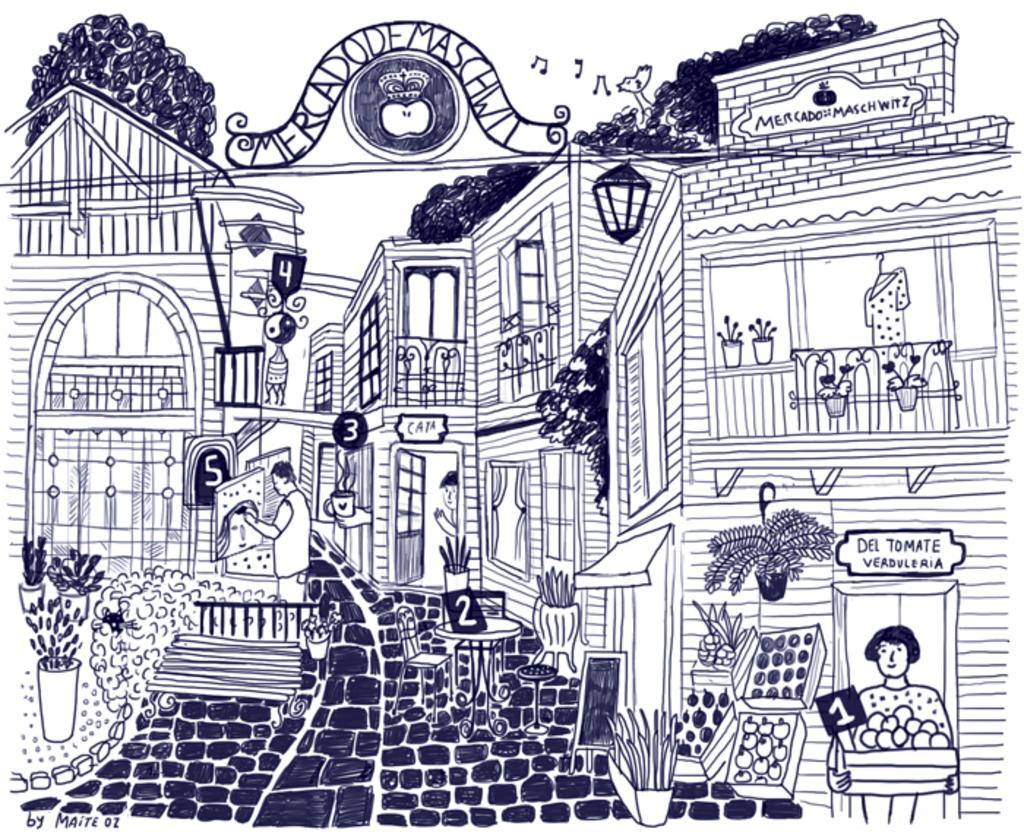What type of artwork is depicted in the image? The image is a drawing. What structures can be seen in the drawing? There are buildings in the drawing. What other objects are present in the drawing? There are boards and plants in the drawing. Are there any people in the drawing? Yes, there are persons in the drawing. What type of government is depicted in the drawing? There is no indication of a government in the drawing; it features buildings, boards, plants, and persons. What smell can be detected from the drawing? Drawings are visual art forms and do not have a smell. 